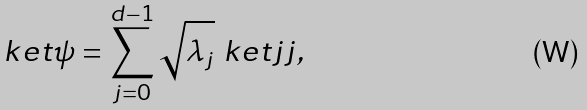Convert formula to latex. <formula><loc_0><loc_0><loc_500><loc_500>\ k e t { \psi } = \sum _ { j = 0 } ^ { d - 1 } \sqrt { \lambda _ { j } } \ k e t { j j } ,</formula> 